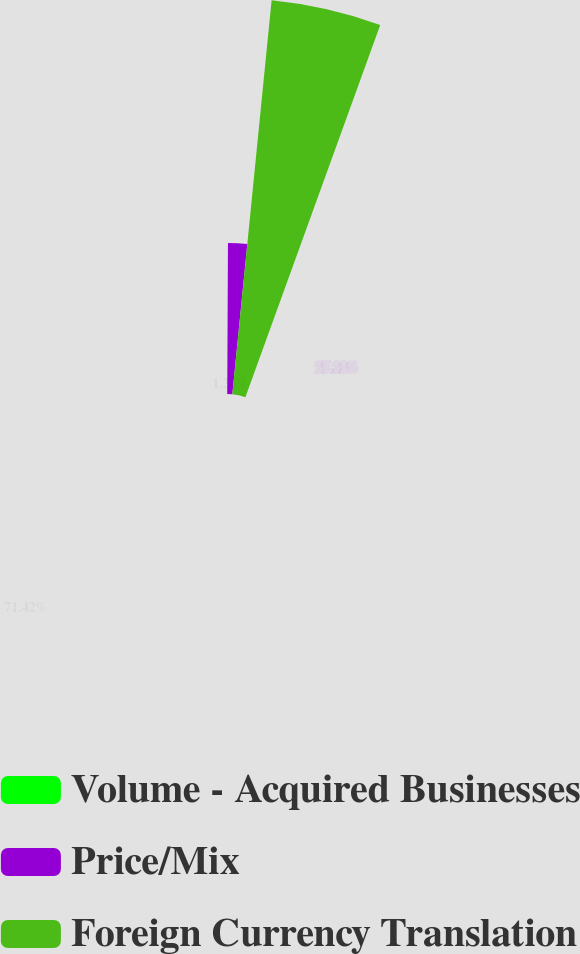Convert chart to OTSL. <chart><loc_0><loc_0><loc_500><loc_500><pie_chart><fcel>Volume - Acquired Businesses<fcel>Price/Mix<fcel>Foreign Currency Translation<nl><fcel>1.36%<fcel>27.22%<fcel>71.42%<nl></chart> 